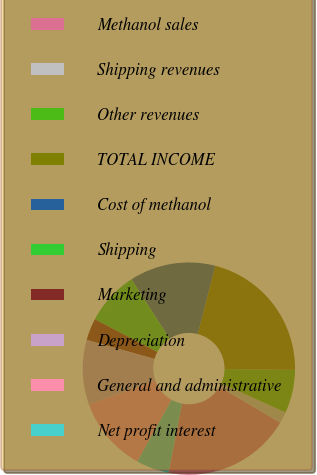<chart> <loc_0><loc_0><loc_500><loc_500><pie_chart><fcel>Methanol sales<fcel>Shipping revenues<fcel>Other revenues<fcel>TOTAL INCOME<fcel>Cost of methanol<fcel>Shipping<fcel>Marketing<fcel>Depreciation<fcel>General and administrative<fcel>Net profit interest<nl><fcel>19.58%<fcel>1.72%<fcel>6.59%<fcel>21.2%<fcel>13.09%<fcel>8.21%<fcel>3.34%<fcel>9.84%<fcel>11.46%<fcel>4.97%<nl></chart> 